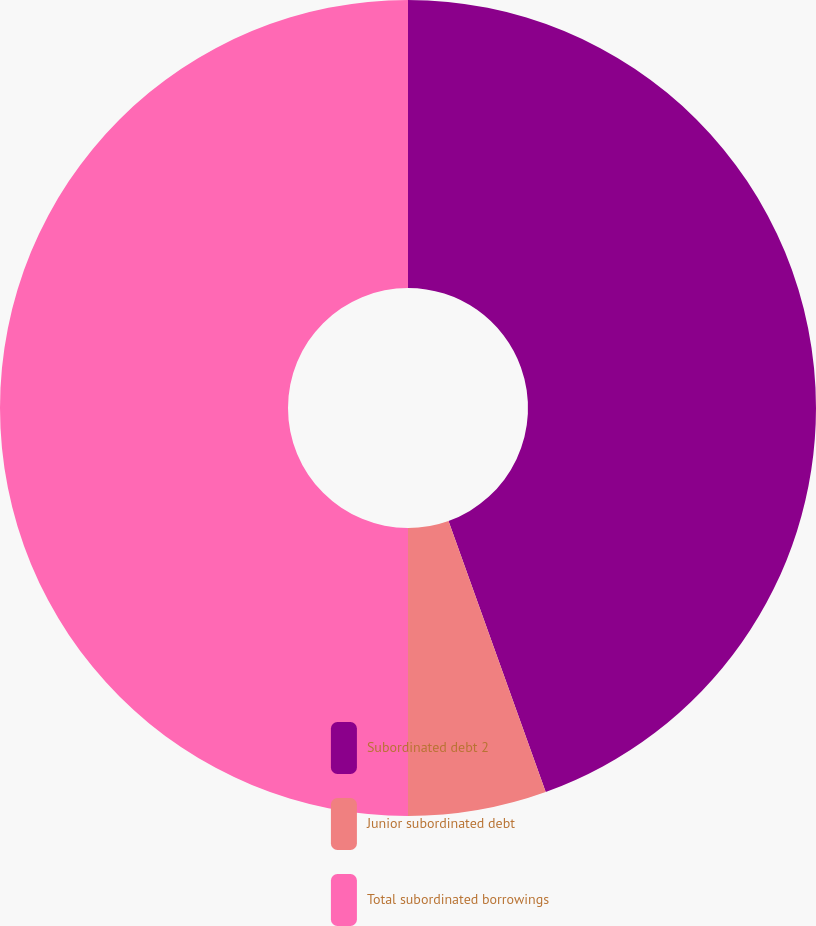<chart> <loc_0><loc_0><loc_500><loc_500><pie_chart><fcel>Subordinated debt 2<fcel>Junior subordinated debt<fcel>Total subordinated borrowings<nl><fcel>44.52%<fcel>5.48%<fcel>50.0%<nl></chart> 